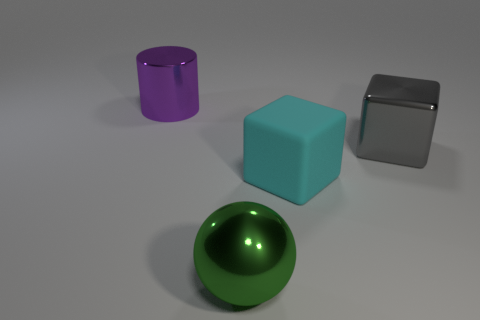Add 2 tiny green matte objects. How many objects exist? 6 Subtract all large red metal balls. Subtract all cubes. How many objects are left? 2 Add 1 large shiny blocks. How many large shiny blocks are left? 2 Add 3 gray cubes. How many gray cubes exist? 4 Subtract 0 purple blocks. How many objects are left? 4 